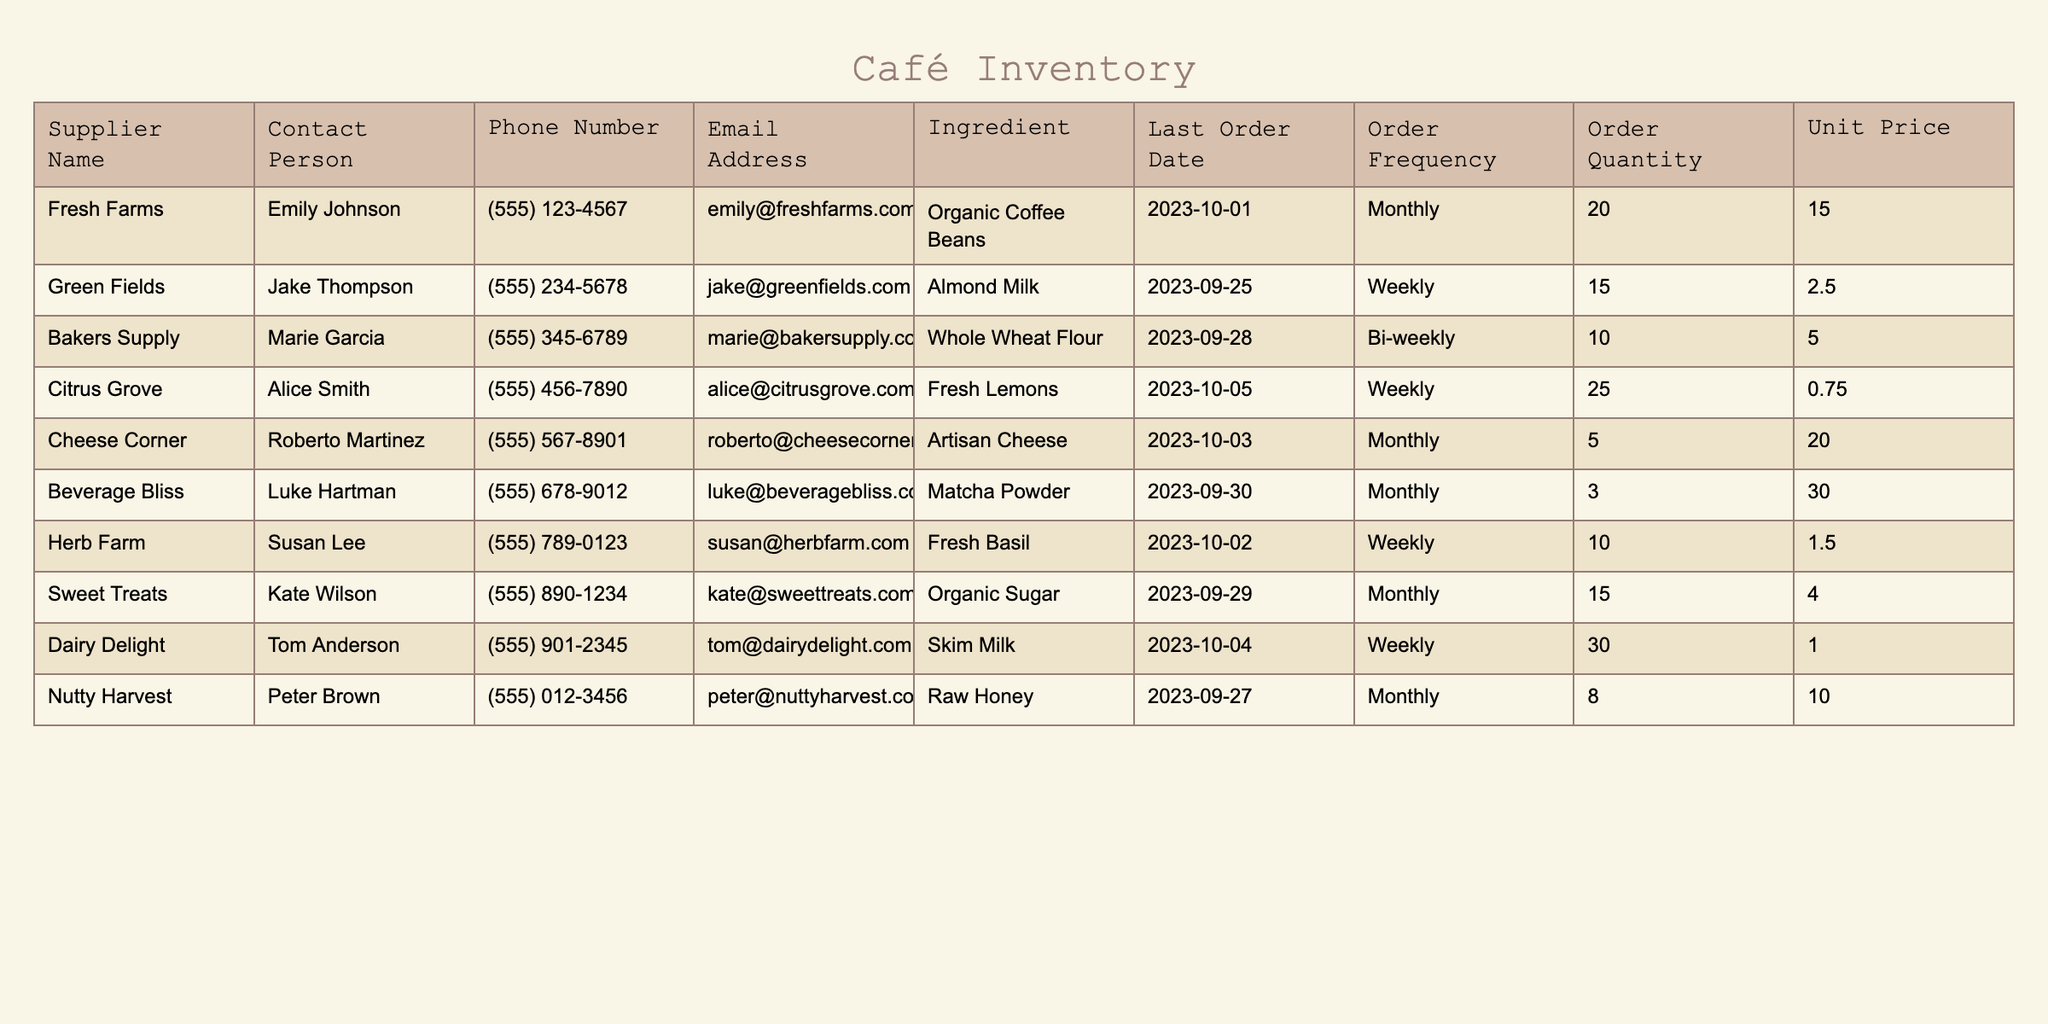What is the contact number for Fresh Farms? In the table, look for the row under "Fresh Farms." The "Phone Number" column has the contact number, which is (555) 123-4567.
Answer: (555) 123-4567 What ingredients are supplied by Dairy Delight? In the table, find the row associated with "Dairy Delight." The "Ingredient" column indicates that they supply Skim Milk.
Answer: Skim Milk How many units of Whole Wheat Flour does Bakers Supply deliver per order? Locate the row for "Bakers Supply" and refer to the "Order Quantity" column, which shows they deliver 10 units per order.
Answer: 10 What is the total order quantity for all ingredients supplied on a monthly basis? Identify all the suppliers with an "Order Frequency" of "Monthly," which are Fresh Farms, Cheese Corner, Beverage Bliss, and Nutty Harvest. Sum their order quantities: 20 + 5 + 3 + 8 = 36.
Answer: 36 Is it true that all suppliers deliver their ingredients weekly? Check the "Order Frequency" column. Not all suppliers have "Weekly" as their frequency; for example, Fresh Farms, Cheese Corner, Beverage Bliss, and Nutty Harvest have "Monthly" deliveries, which confirms that the statement is false.
Answer: No What is the average unit price of the ingredients supplied by all listed suppliers? Calculate the average unit price: Sum all unit prices (15.00 + 2.50 + 5.00 + 0.75 + 20.00 + 30.00 + 1.50 + 4.00 + 1.00 + 10.00 = 85.75) and divide by the number of suppliers (10), resulting in 85.75 / 10 = 8.575.
Answer: 8.575 Which supplier last placed an order for ingredients on October 5, 2023? Look for the "Last Order Date" in the table and find the row with the date October 5, 2023, which corresponds to Citrus Grove.
Answer: Citrus Grove How many ingredients have an order frequency of bi-weekly? Examine the "Order Frequency" column and count rows where the frequency is "Bi-weekly." Only one supplier, Bakers Supply, has this frequency, indicating there is 1 ingredient.
Answer: 1 What is the price difference between the most expensive unit and the cheapest unit of ingredients? Identify the "Unit Price" column for the maximum price (30.00 for Matcha Powder) and the minimum price (0.75 for Fresh Lemons). The difference is 30.00 - 0.75 = 29.25.
Answer: 29.25 